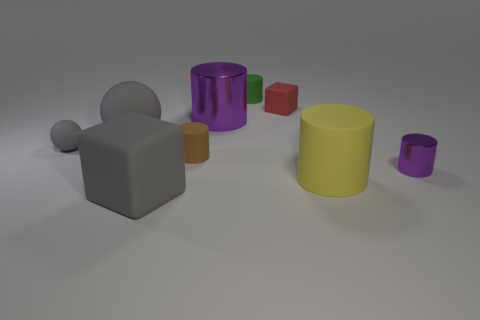Subtract 1 cylinders. How many cylinders are left? 4 Subtract all green cylinders. How many cylinders are left? 4 Subtract all tiny brown cylinders. How many cylinders are left? 4 Subtract all cyan cylinders. Subtract all red blocks. How many cylinders are left? 5 Subtract all balls. How many objects are left? 7 Subtract all large brown shiny cylinders. Subtract all small green matte objects. How many objects are left? 8 Add 5 big rubber spheres. How many big rubber spheres are left? 6 Add 6 tiny shiny balls. How many tiny shiny balls exist? 6 Subtract 0 cyan cubes. How many objects are left? 9 